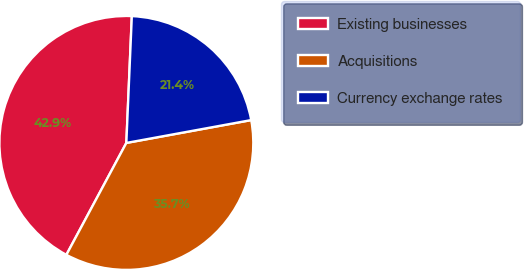Convert chart. <chart><loc_0><loc_0><loc_500><loc_500><pie_chart><fcel>Existing businesses<fcel>Acquisitions<fcel>Currency exchange rates<nl><fcel>42.86%<fcel>35.71%<fcel>21.43%<nl></chart> 